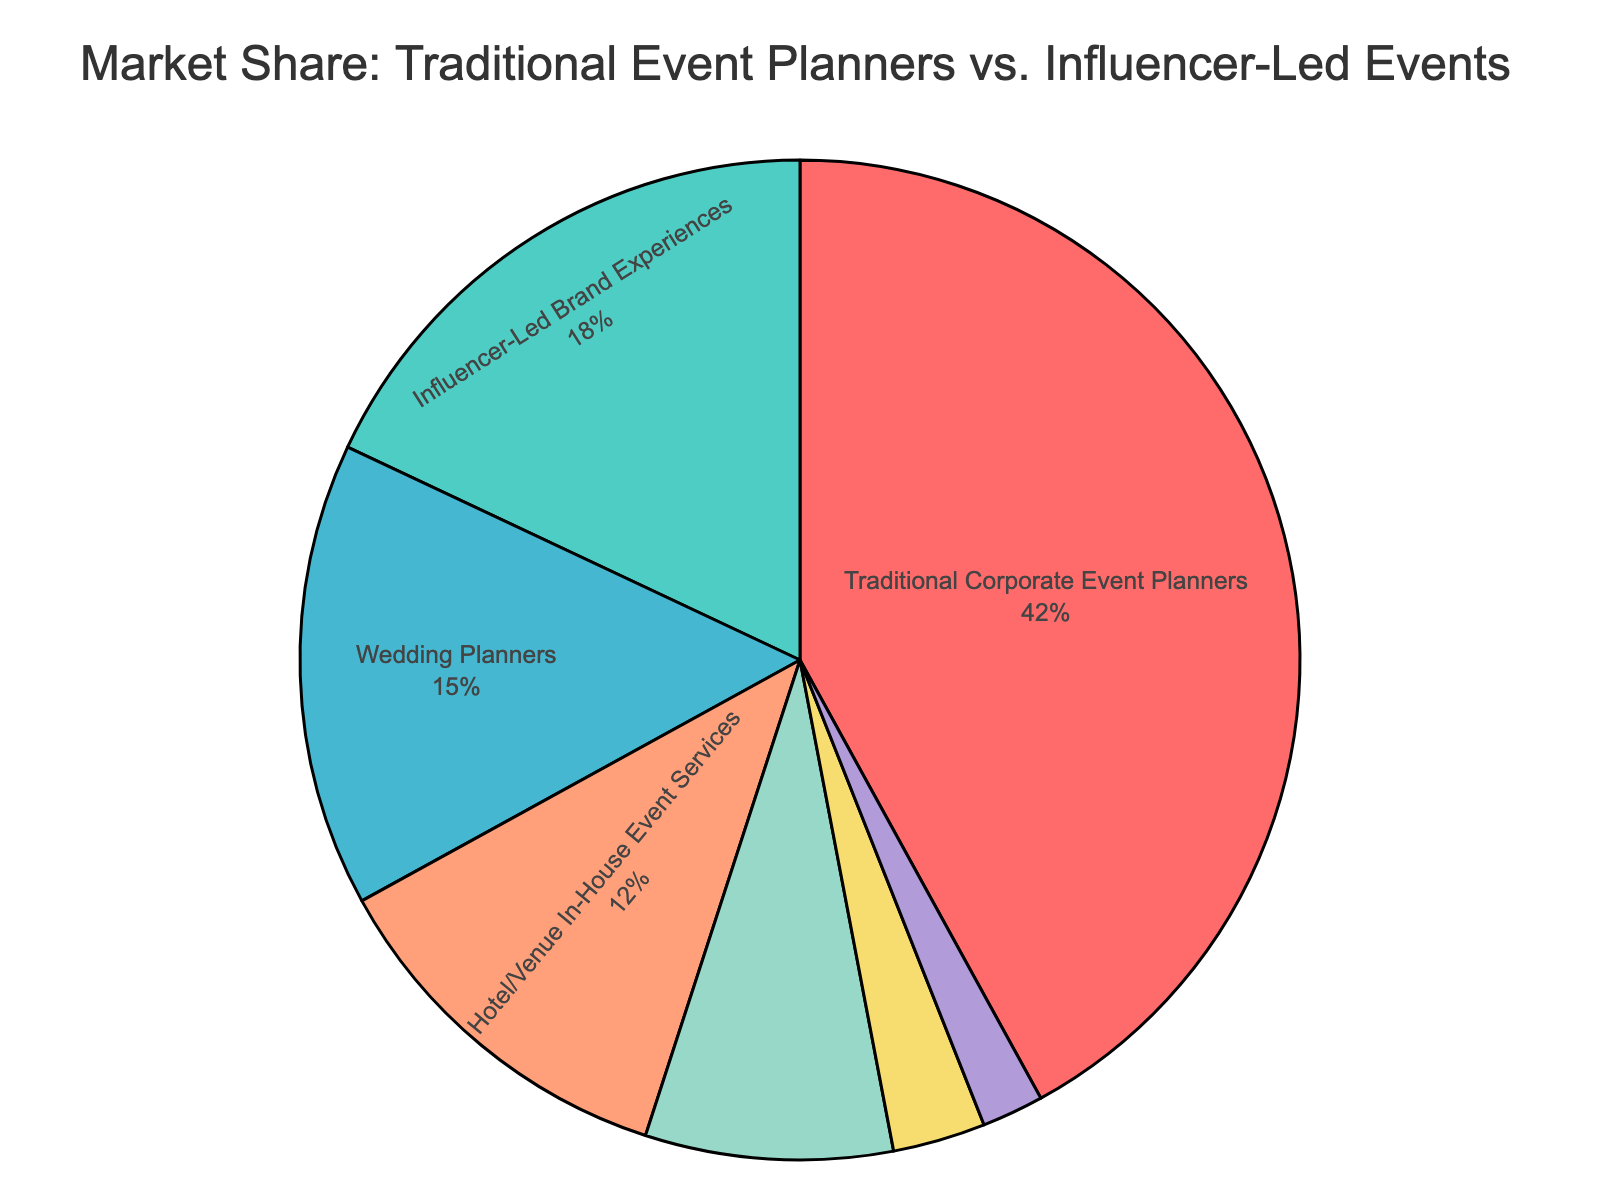What is the market share of Traditional Corporate Event Planners? Look at the section labeled "Traditional Corporate Event Planners" in the pie chart. The percentage given is 42%.
Answer: 42% Which event type has the smallest market share? Find the segment with the smallest percentage. "Social Media Platform Event Tools" has a market share of 2%, which is the smallest.
Answer: Social Media Platform Event Tools How does the market share of Influencer-Led Brand Experiences compare to Wedding Planners? Compare the percentages of "Influencer-Led Brand Experiences" (18%) and "Wedding Planners" (15%). Influencer-Led Brand Experiences have a higher market share.
Answer: Influencer-Led Brand Experiences has a higher market share What is the combined market share of Wedding Planners and Hotel/Venue In-House Event Services? Add the percentages of "Wedding Planners" (15%) and "Hotel/Venue In-House Event Services" (12%). 15% + 12% = 27%.
Answer: 27% What is the difference in market share between Traditional Corporate Event Planners and Destination Management Companies? Subtract the market share of "Destination Management Companies" (8%) from "Traditional Corporate Event Planners" (42%). 42% - 8% = 34%.
Answer: 34% What fraction of the market share is held by Non-Profit Event Organizers? "Non-Profit Event Organizers" have a market share of 3%. To convert this into a fraction of the total market (which is 100%), it remains 3/100.
Answer: 3/100 Which event type holds more market share, Hotel/Venue In-House Event Services or Social Media Platform Event Tools? Compare the market shares of "Hotel/Venue In-House Event Services" (12%) and "Social Media Platform Event Tools" (2%). Hotel/Venue In-House Event Services has a higher market share.
Answer: Hotel/Venue In-House Event Services List the event types in descending order of their market shares. Order the event types based on their percentages: Traditional Corporate Event Planners (42%), Influencer-Led Brand Experiences (18%), Wedding Planners (15%), Hotel/Venue In-House Event Services (12%), Destination Management Companies (8%), Non-Profit Event Organizers (3%), Social Media Platform Event Tools (2%).
Answer: Traditional Corporate Event Planners, Influencer-Led Brand Experiences, Wedding Planners, Hotel/Venue In-House Event Services, Destination Management Companies, Non-Profit Event Organizers, Social Media Platform Event Tools Is the market share of Influencer-Led Brand Experiences more than double that of Non-Profit Event Organizers? Double the market share of Non-Profit Event Organizers (3%) is 6%. Compare this with the market share of Influencer-Led Brand Experiences (18%). Since 18% > 6%, the market share of Influencer-Led Brand Experiences is indeed more than double.
Answer: Yes 